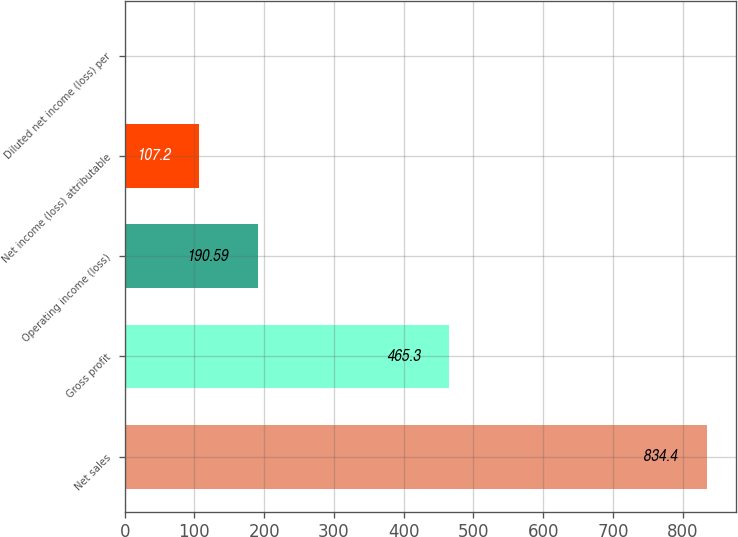<chart> <loc_0><loc_0><loc_500><loc_500><bar_chart><fcel>Net sales<fcel>Gross profit<fcel>Operating income (loss)<fcel>Net income (loss) attributable<fcel>Diluted net income (loss) per<nl><fcel>834.4<fcel>465.3<fcel>190.59<fcel>107.2<fcel>0.46<nl></chart> 